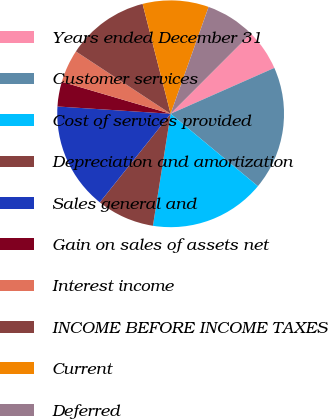Convert chart to OTSL. <chart><loc_0><loc_0><loc_500><loc_500><pie_chart><fcel>Years ended December 31<fcel>Customer services<fcel>Cost of services provided<fcel>Depreciation and amortization<fcel>Sales general and<fcel>Gain on sales of assets net<fcel>Interest income<fcel>INCOME BEFORE INCOME TAXES<fcel>Current<fcel>Deferred<nl><fcel>5.88%<fcel>17.65%<fcel>16.47%<fcel>8.24%<fcel>15.29%<fcel>3.53%<fcel>4.71%<fcel>11.76%<fcel>9.41%<fcel>7.06%<nl></chart> 